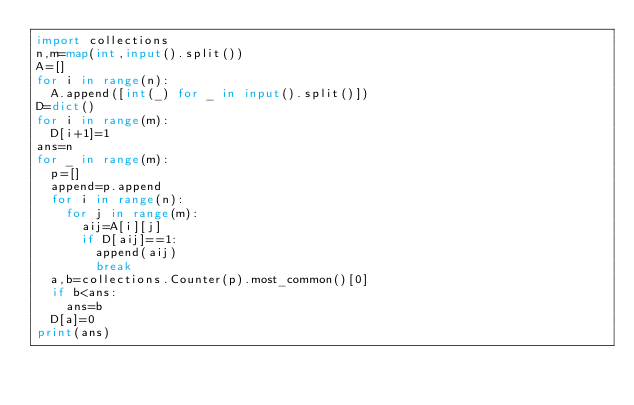<code> <loc_0><loc_0><loc_500><loc_500><_Python_>import collections
n,m=map(int,input().split())
A=[]
for i in range(n):
  A.append([int(_) for _ in input().split()])
D=dict()
for i in range(m):
  D[i+1]=1
ans=n
for _ in range(m):
  p=[]
  append=p.append
  for i in range(n):
    for j in range(m):
      aij=A[i][j]
      if D[aij]==1:
        append(aij)
        break
  a,b=collections.Counter(p).most_common()[0]
  if b<ans:
    ans=b
  D[a]=0
print(ans)</code> 